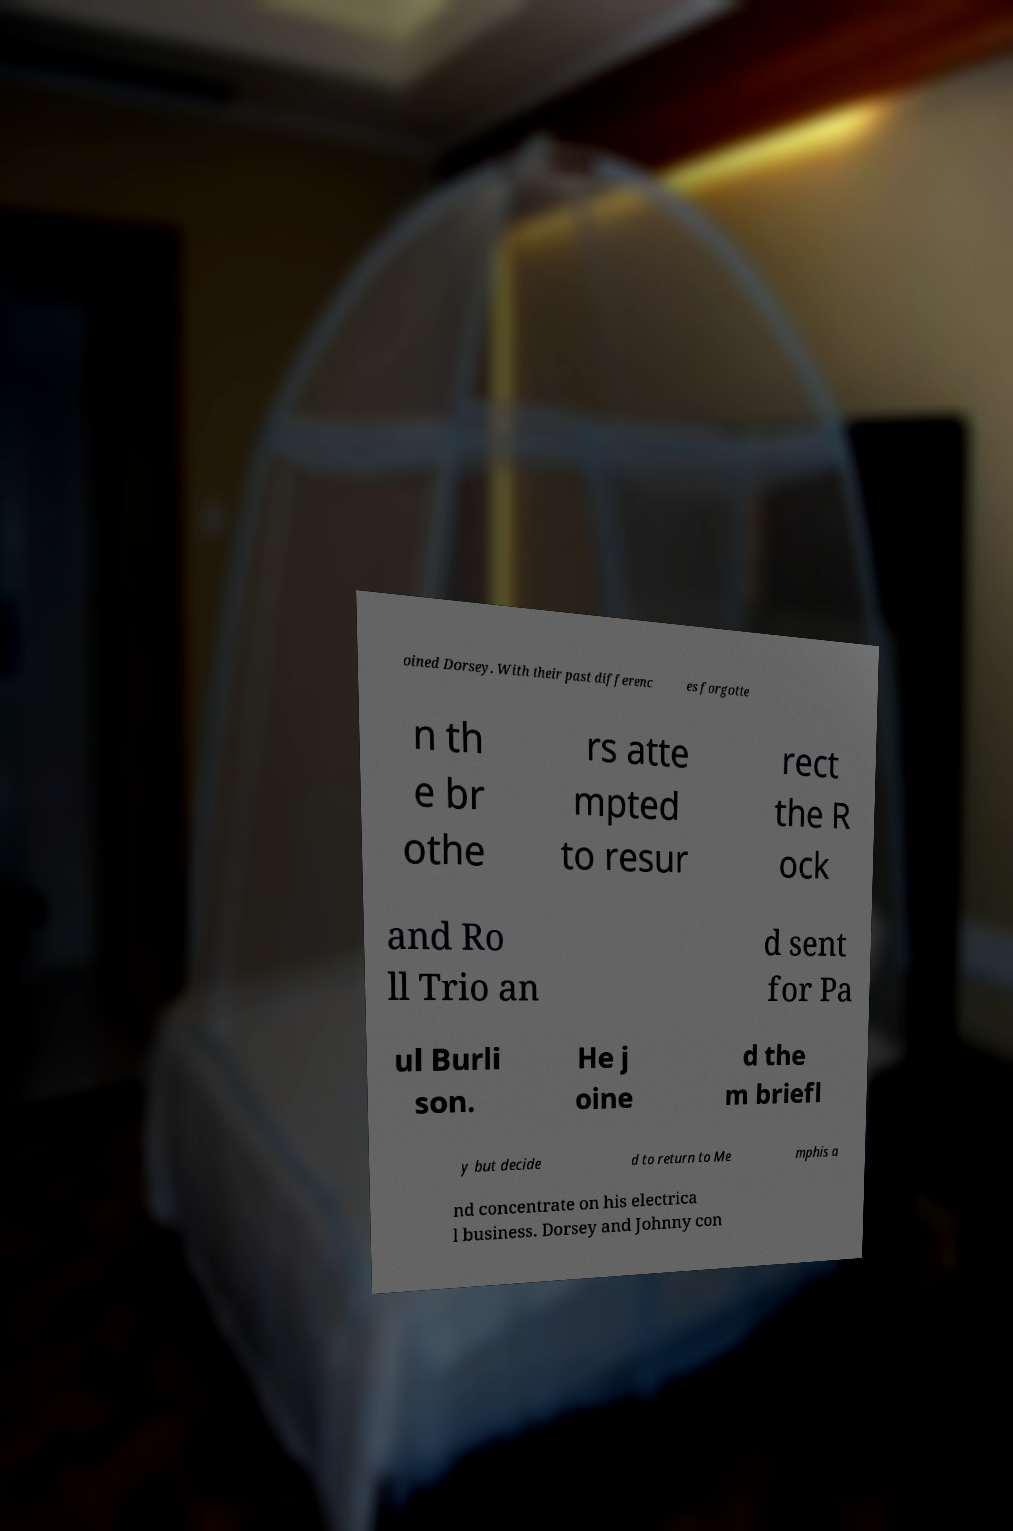Can you read and provide the text displayed in the image?This photo seems to have some interesting text. Can you extract and type it out for me? oined Dorsey. With their past differenc es forgotte n th e br othe rs atte mpted to resur rect the R ock and Ro ll Trio an d sent for Pa ul Burli son. He j oine d the m briefl y but decide d to return to Me mphis a nd concentrate on his electrica l business. Dorsey and Johnny con 